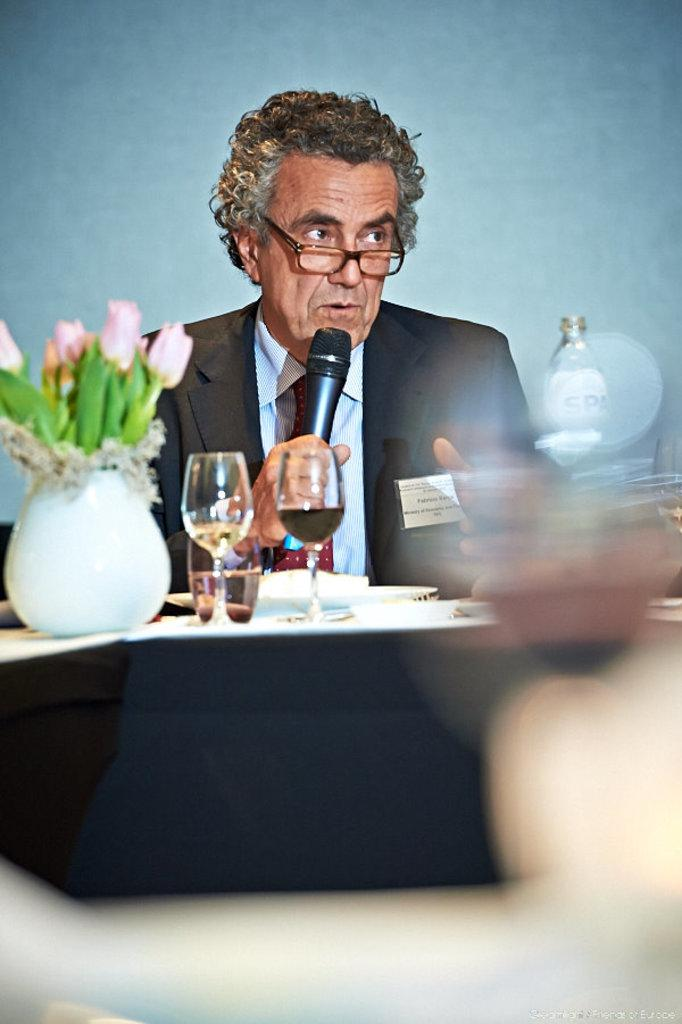Who is the main subject in the image? There is a man in the image. What is the man holding in the image? The man is holding a microphone. What object can be seen on the table in the image? There are wine glasses on the table. Can you describe the table in the image? The table is a piece of furniture that holds the wine glasses. How many brothers are present in the image? There is no mention of brothers in the image, so we cannot determine their presence. 